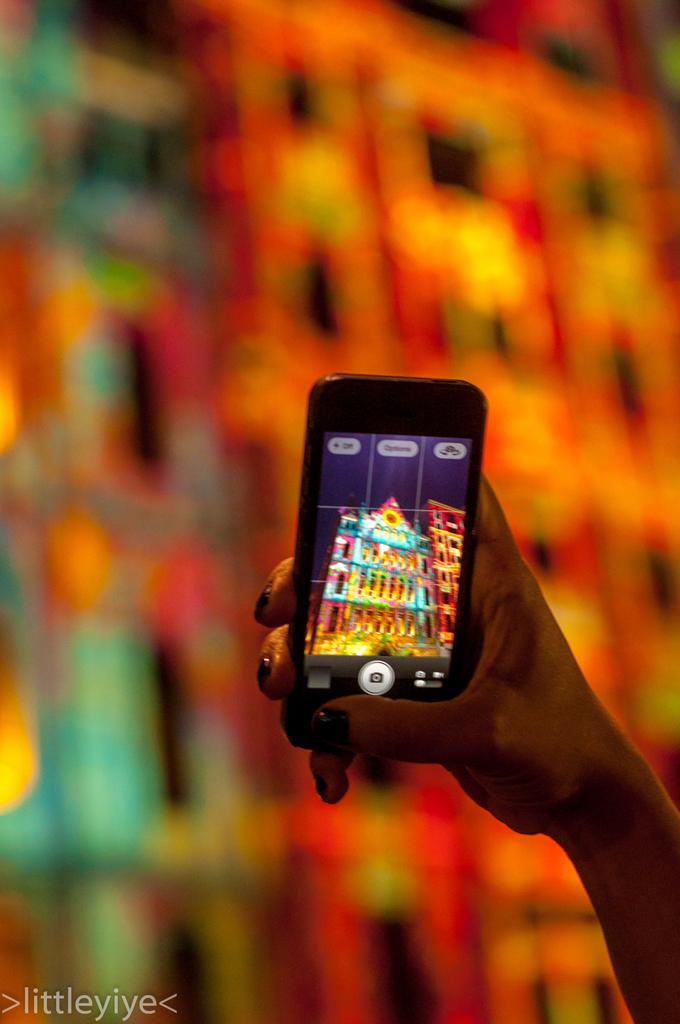Who is the main subject in the image? There is a woman in the image. What is the woman holding in her hand? The woman is holding a mobile phone in her hand. What can be seen on the mobile phone's screen? The mobile phone has a picture of a building on it. How would you describe the background of the image? The background of the image is slightly blurry. What type of cherry is the woman eating in the image? There is no cherry present in the image; the woman is holding a mobile phone with a picture of a building on it. 